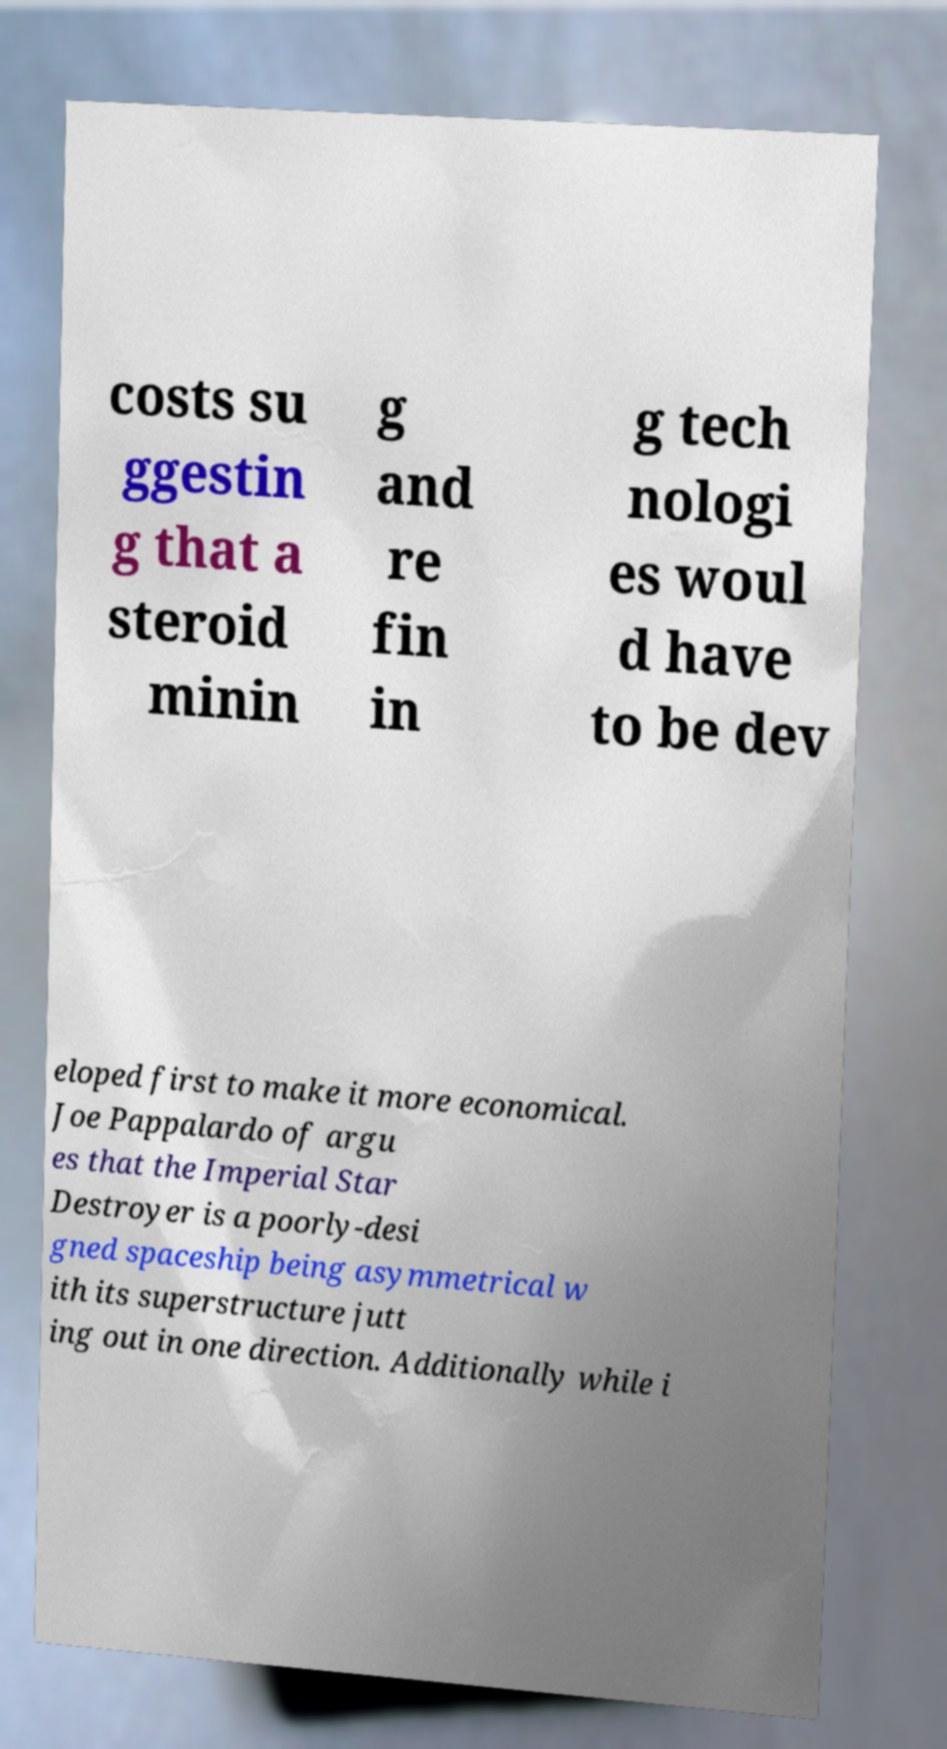Can you accurately transcribe the text from the provided image for me? costs su ggestin g that a steroid minin g and re fin in g tech nologi es woul d have to be dev eloped first to make it more economical. Joe Pappalardo of argu es that the Imperial Star Destroyer is a poorly-desi gned spaceship being asymmetrical w ith its superstructure jutt ing out in one direction. Additionally while i 